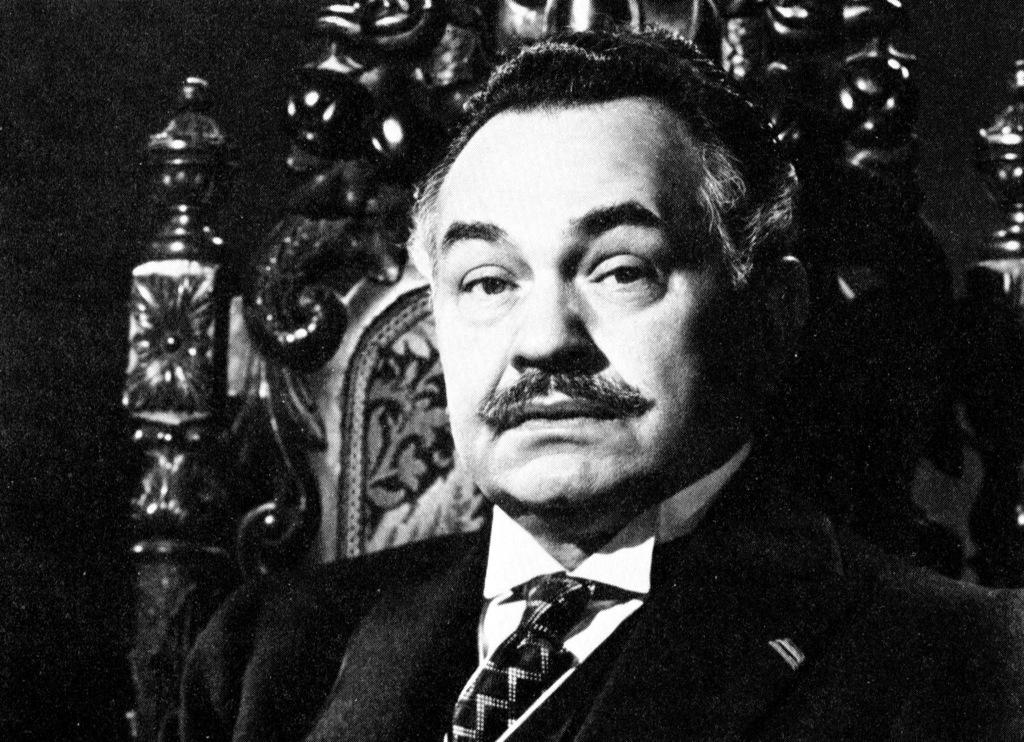Who is present in the image? There is a man in the image. What is the man wearing? The man is wearing a suit. What is the man sitting on? The man is sitting on a wooden chair. What can be seen in the top right corner of the image? There is a wall in the top right corner of the image. How would you describe the lighting on the left side of the image? The left side of the image appears to be dark. Can you see the man's toe wiggling in the image? There is no indication of the man's toes or any movement in the image. What type of summer activity is the man participating in the image? The image does not depict any summer activities, and the man's actions are not specified. 